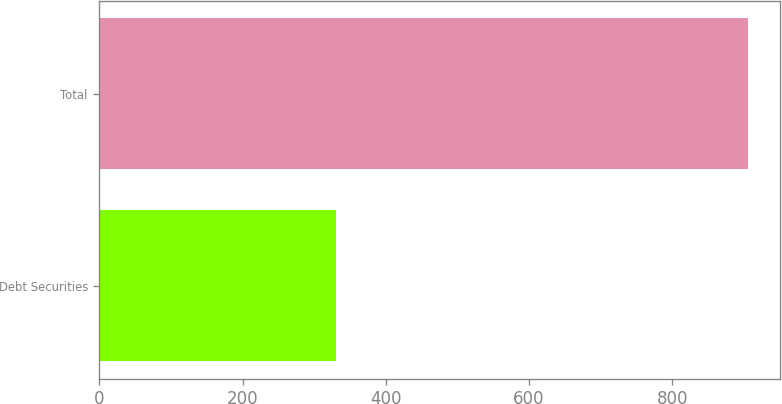Convert chart to OTSL. <chart><loc_0><loc_0><loc_500><loc_500><bar_chart><fcel>Debt Securities<fcel>Total<nl><fcel>330.5<fcel>905.7<nl></chart> 